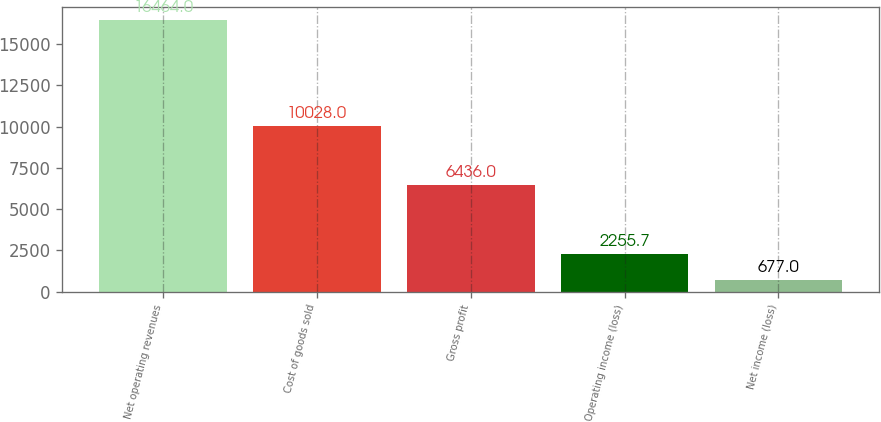Convert chart to OTSL. <chart><loc_0><loc_0><loc_500><loc_500><bar_chart><fcel>Net operating revenues<fcel>Cost of goods sold<fcel>Gross profit<fcel>Operating income (loss)<fcel>Net income (loss)<nl><fcel>16464<fcel>10028<fcel>6436<fcel>2255.7<fcel>677<nl></chart> 